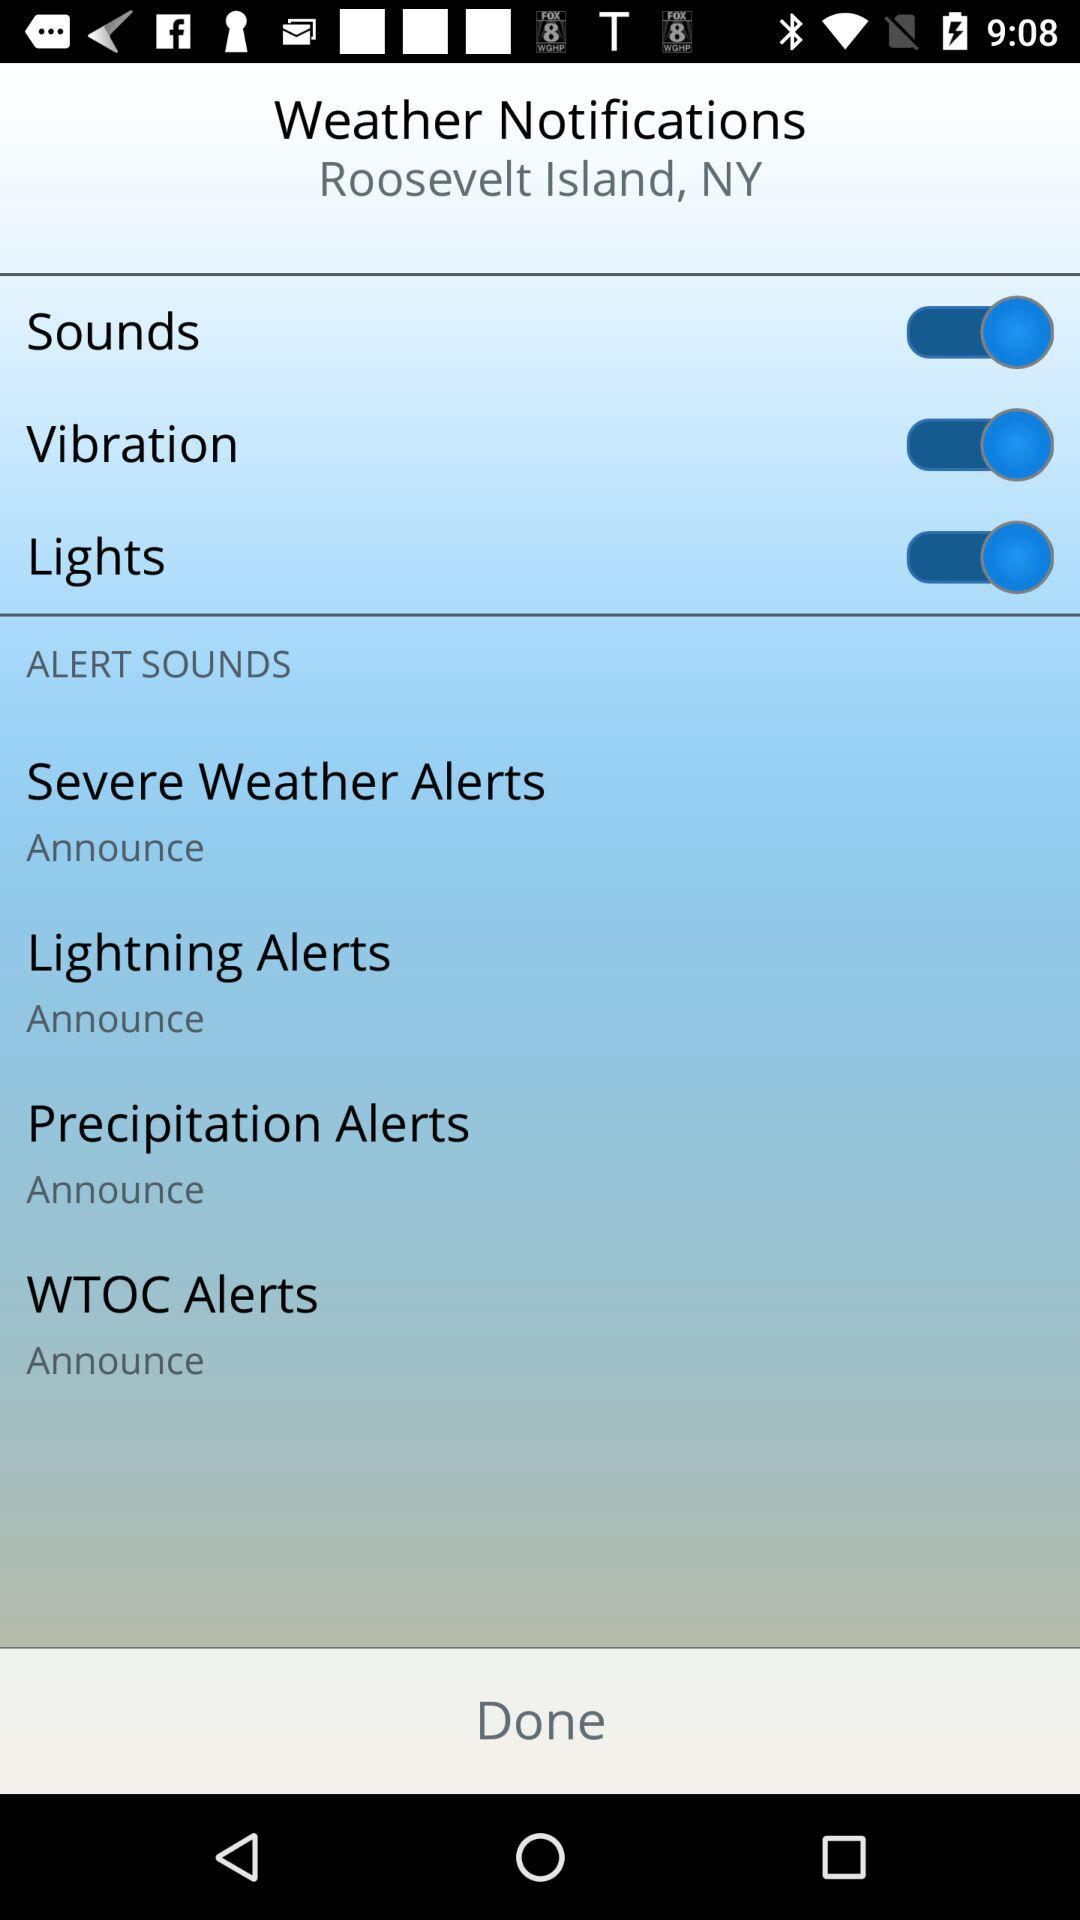What's the selected location name for getting weather notifications? The location is Roosevelt Island, NY. 